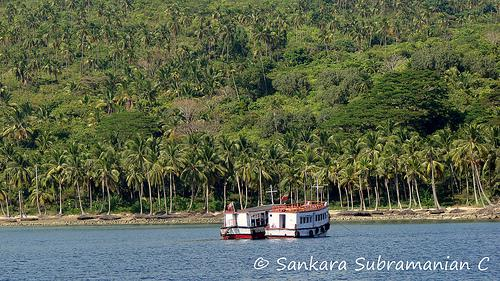Question: what type of tree is along the shore?
Choices:
A. Beech.
B. Hardwood.
C. Palm.
D. Pine.
Answer with the letter. Answer: C Question: what is the first word in the text?
Choices:
A. Apple.
B. Sankara.
C. Balm.
D. Tree.
Answer with the letter. Answer: B Question: what type of symbol is in the text?
Choices:
A. Question Mark.
B. Exclamation Point.
C. Copyright.
D. Period.
Answer with the letter. Answer: C Question: where is this picture taken?
Choices:
A. At the orchard.
B. On the water.
C. At the zoo.
D. On the train.
Answer with the letter. Answer: B Question: how many boats are pictured?
Choices:
A. Three.
B. Two.
C. Four.
D. Five.
Answer with the letter. Answer: B Question: what is the final letter in the text?
Choices:
A. A.
B. E.
C. C.
D. G.
Answer with the letter. Answer: C 